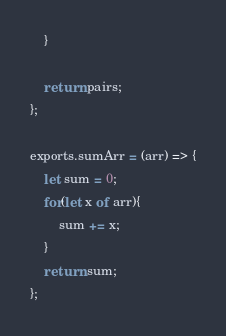<code> <loc_0><loc_0><loc_500><loc_500><_JavaScript_>    }
    
    return pairs;
};

exports.sumArr = (arr) => {
    let sum = 0;
    for(let x of arr){
        sum += x;
    }
    return sum;
};

</code> 